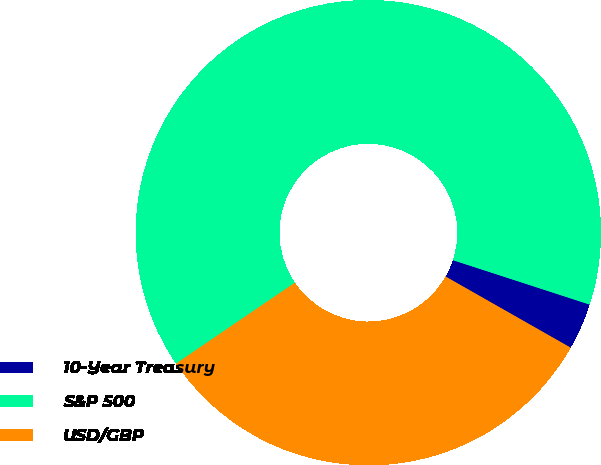Convert chart to OTSL. <chart><loc_0><loc_0><loc_500><loc_500><pie_chart><fcel>10-Year Treasury<fcel>S&P 500<fcel>USD/GBP<nl><fcel>3.23%<fcel>64.52%<fcel>32.26%<nl></chart> 